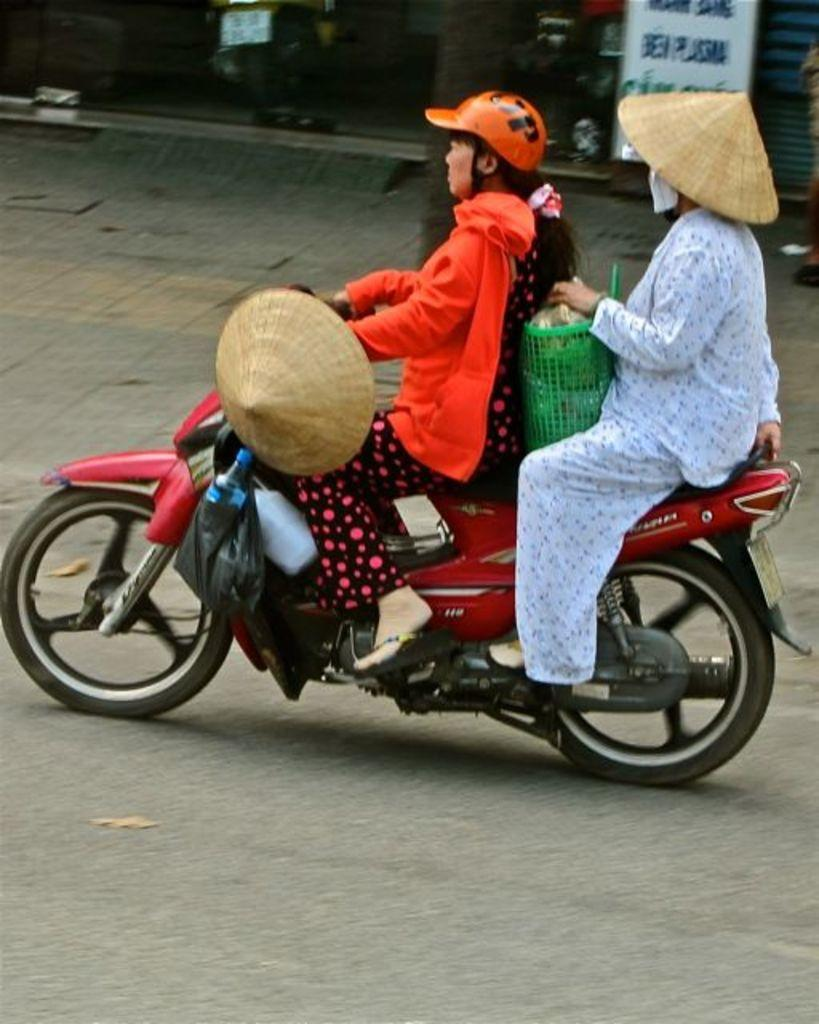How many people are in the image? There are two people in the image. What are the two people doing in the image? The two people are sitting on a motorcycle. What is the background of the image? There is a road visible in the image. What type of collar is the daughter wearing in the image? There is no mention of a daughter or collar in the image, so it is not possible to answer that question. 